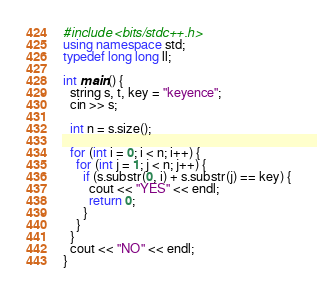<code> <loc_0><loc_0><loc_500><loc_500><_C++_>#include <bits/stdc++.h>
using namespace std;
typedef long long ll;

int main() {
  string s, t, key = "keyence";
  cin >> s;

  int n = s.size();

  for (int i = 0; i < n; i++) {
    for (int j = 1; j < n; j++) {
      if (s.substr(0, i) + s.substr(j) == key) {
        cout << "YES" << endl;
        return 0;
      }
    }
  }
  cout << "NO" << endl;
}
</code> 